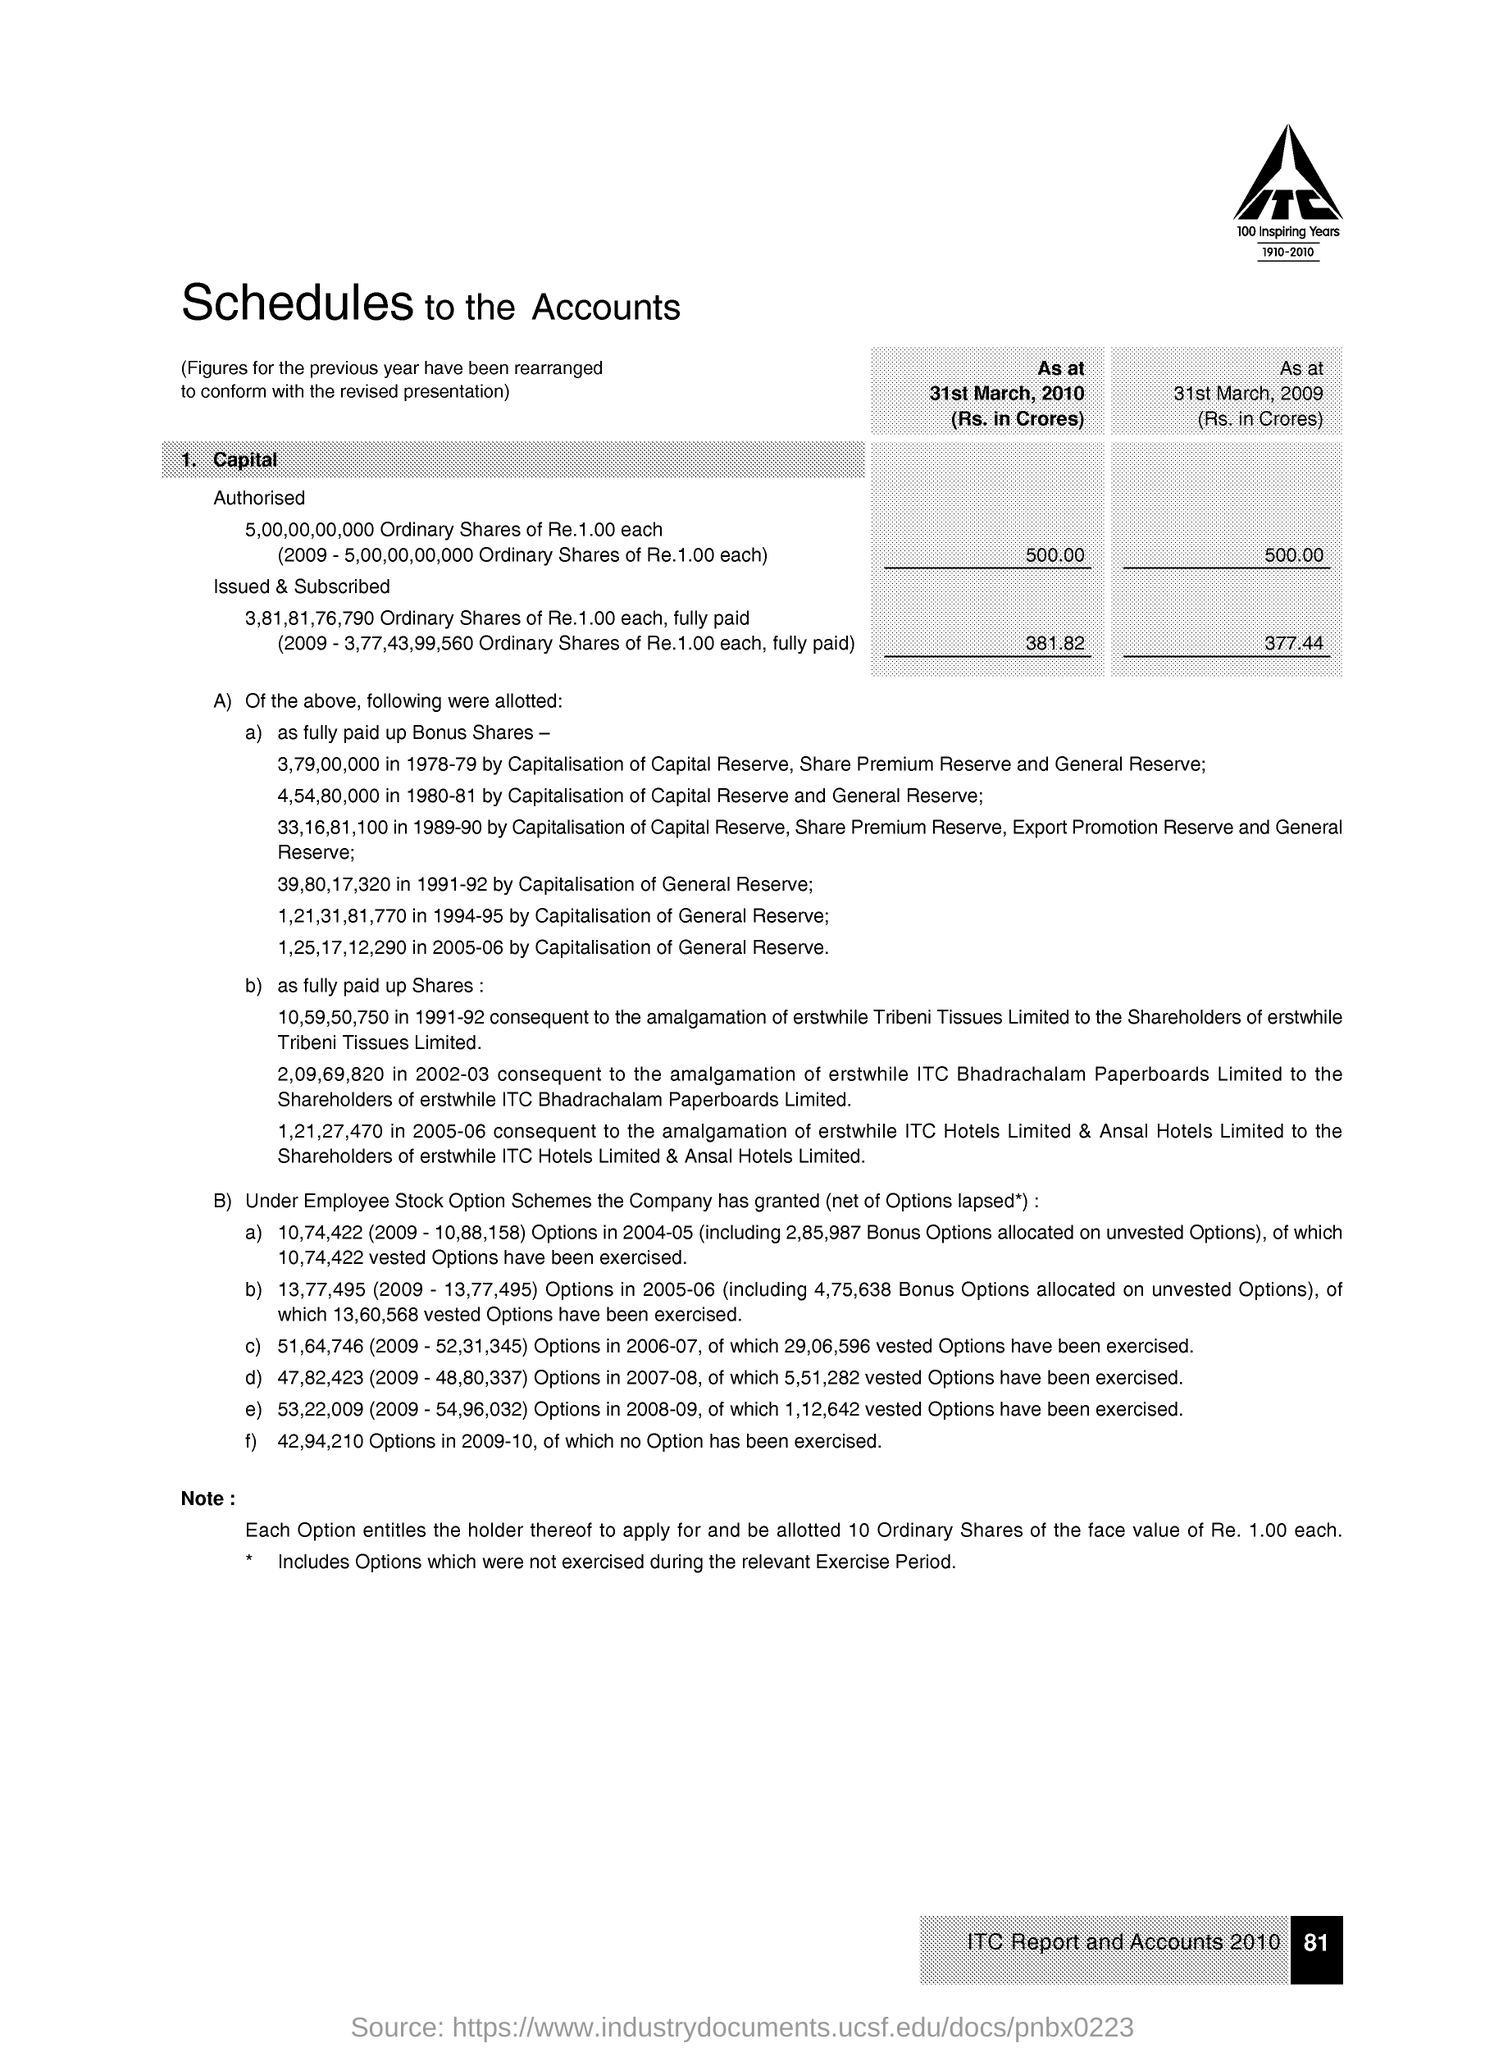List a handful of essential elements in this visual. The text below the image reads '100 INSPIRING YEARS 1910-2010.'. The title of the document is 'Schedules to the Accounts'. Page 81 is the page number. The image contains the text 'ITC..'. 